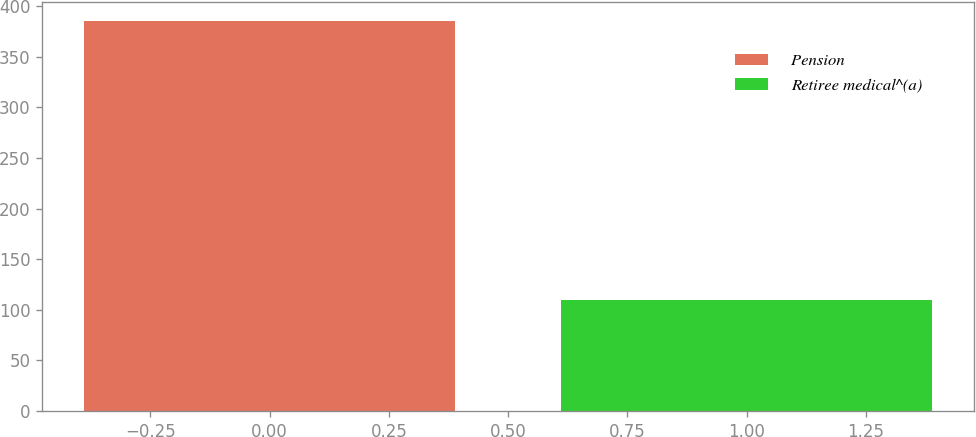Convert chart to OTSL. <chart><loc_0><loc_0><loc_500><loc_500><bar_chart><fcel>Pension<fcel>Retiree medical^(a)<nl><fcel>385<fcel>110<nl></chart> 